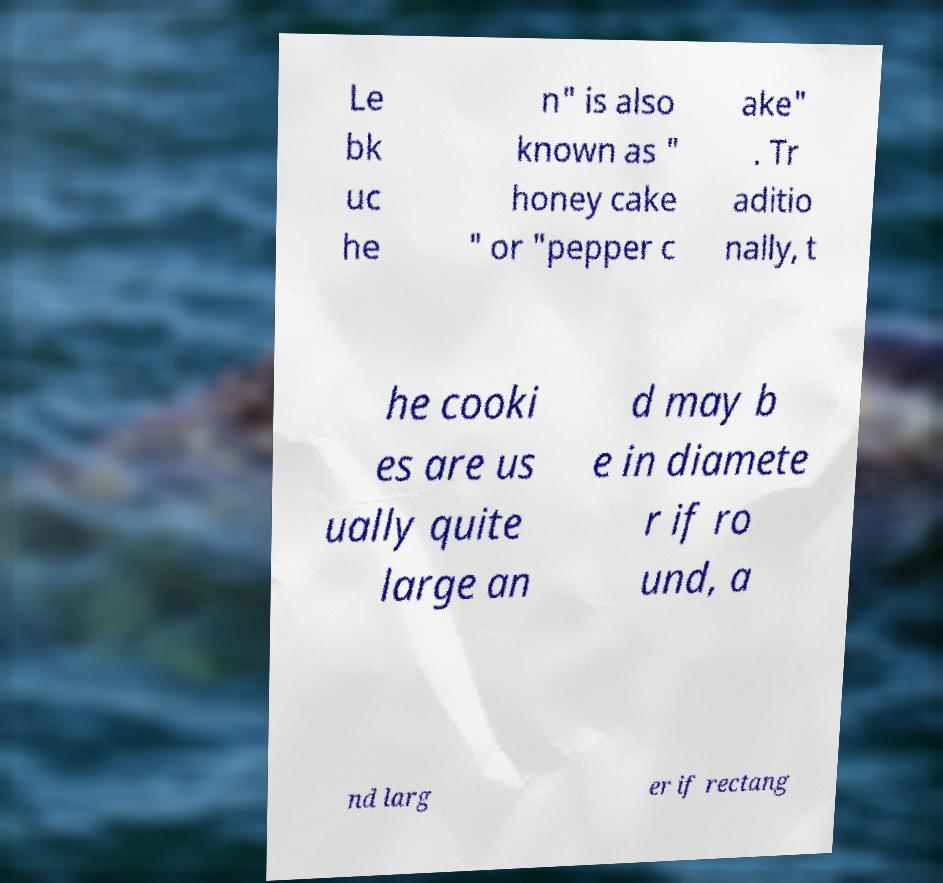Please read and relay the text visible in this image. What does it say? Le bk uc he n" is also known as " honey cake " or "pepper c ake" . Tr aditio nally, t he cooki es are us ually quite large an d may b e in diamete r if ro und, a nd larg er if rectang 